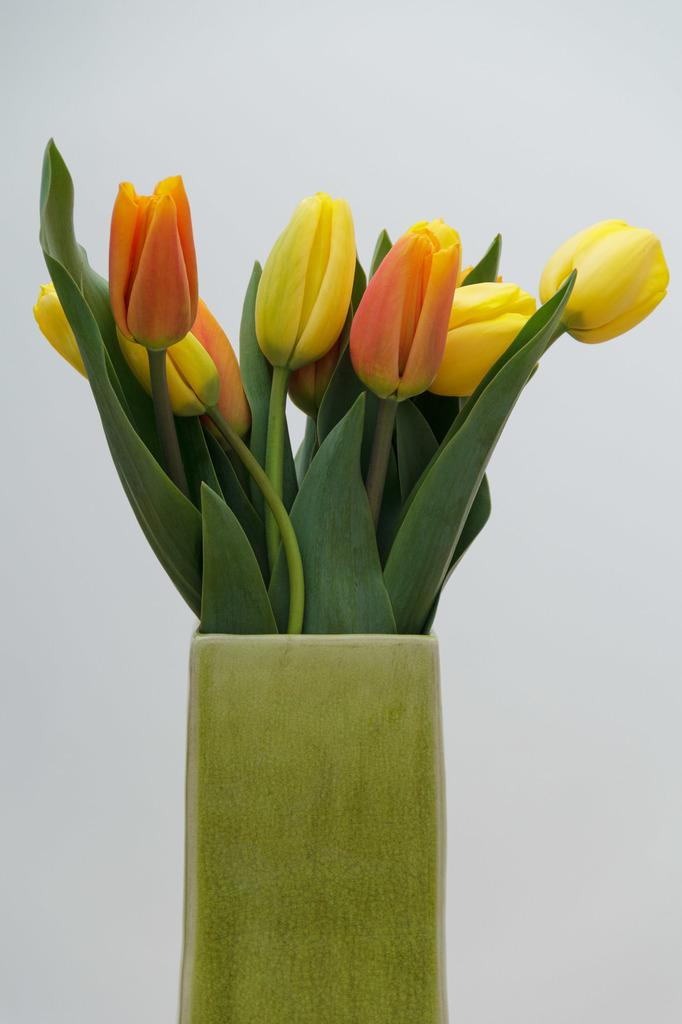What object is present in the image that is used for holding plants? There is a flower pot in the image. What type of structure can be seen in the background of the image? There is a wall visible in the image. What type of drink is being served in the flower pot in the image? There is no drink being served in the flower pot in the image; it is used for holding plants. How many houses are visible in the image? There are no houses visible in the image; only a flower pot and a wall are present. 